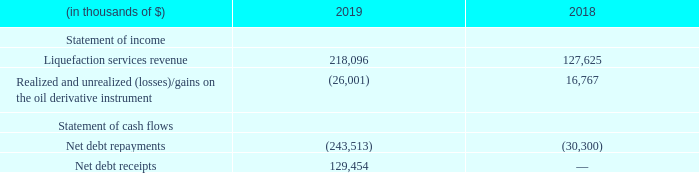Summarized financial information of Hilli LLC
The most significant impacts of Hilli LLC VIE's operations on our consolidated statements of income and consolidated statements of cash flows, as of December 31, 2019 and 2018, are as follows:
In which years was the financial information recorded for? 2019, 2018. What was the net debt receipts in 2019?
Answer scale should be: thousand. 129,454. What was the net debt repayments in 2018?
Answer scale should be: thousand. (30,300). In which year was the realized and unrealized (losses)/gains on the oil derivative instrument higher? 16,767 > (26,001)
Answer: 2018. What was the change in net debt receipts between 2018 and 2019?
Answer scale should be: thousand. 129,454 - 0 
Answer: 129454. What was the percentage change in liquefaction services revenue between 2018 and 2019?
Answer scale should be: percent. (218,096 - 127,625)/127,625 
Answer: 70.89. 